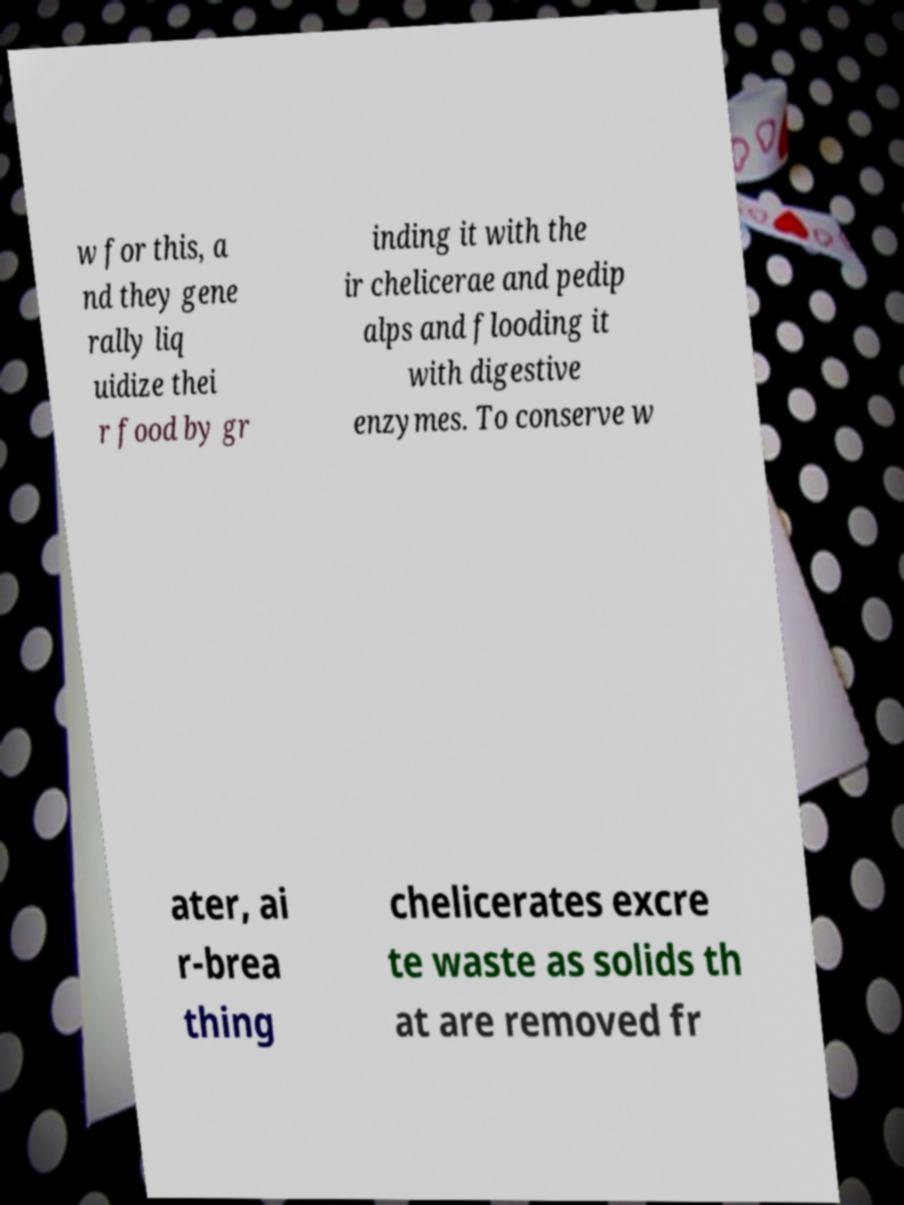What messages or text are displayed in this image? I need them in a readable, typed format. w for this, a nd they gene rally liq uidize thei r food by gr inding it with the ir chelicerae and pedip alps and flooding it with digestive enzymes. To conserve w ater, ai r-brea thing chelicerates excre te waste as solids th at are removed fr 